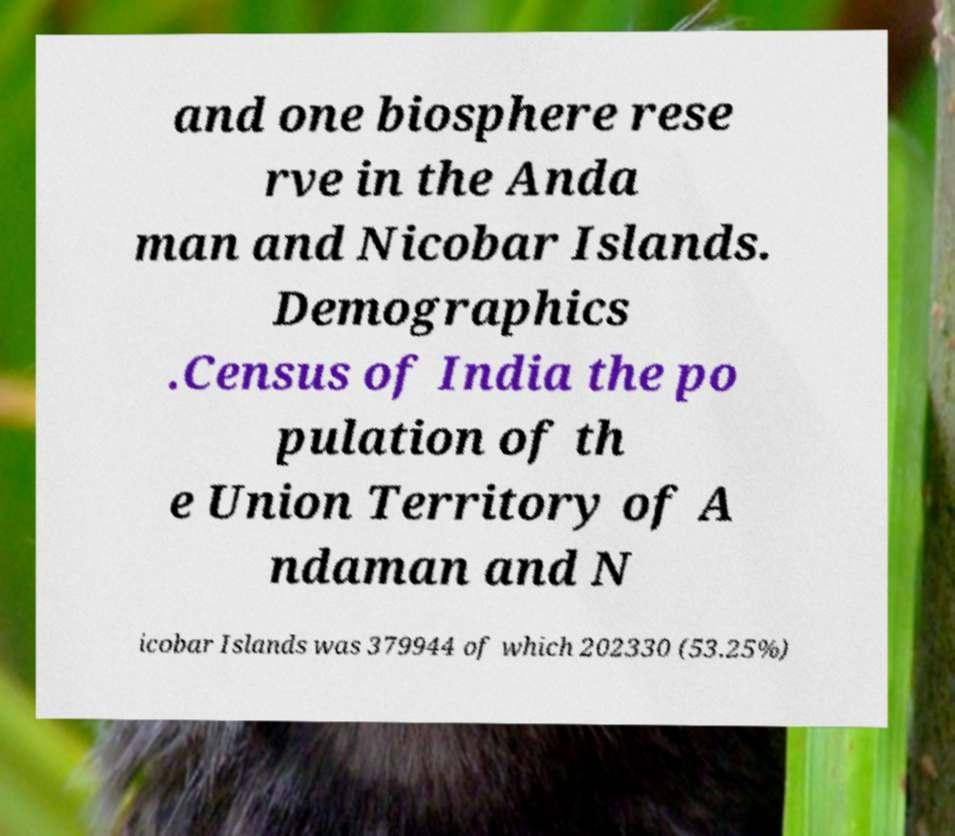What messages or text are displayed in this image? I need them in a readable, typed format. and one biosphere rese rve in the Anda man and Nicobar Islands. Demographics .Census of India the po pulation of th e Union Territory of A ndaman and N icobar Islands was 379944 of which 202330 (53.25%) 